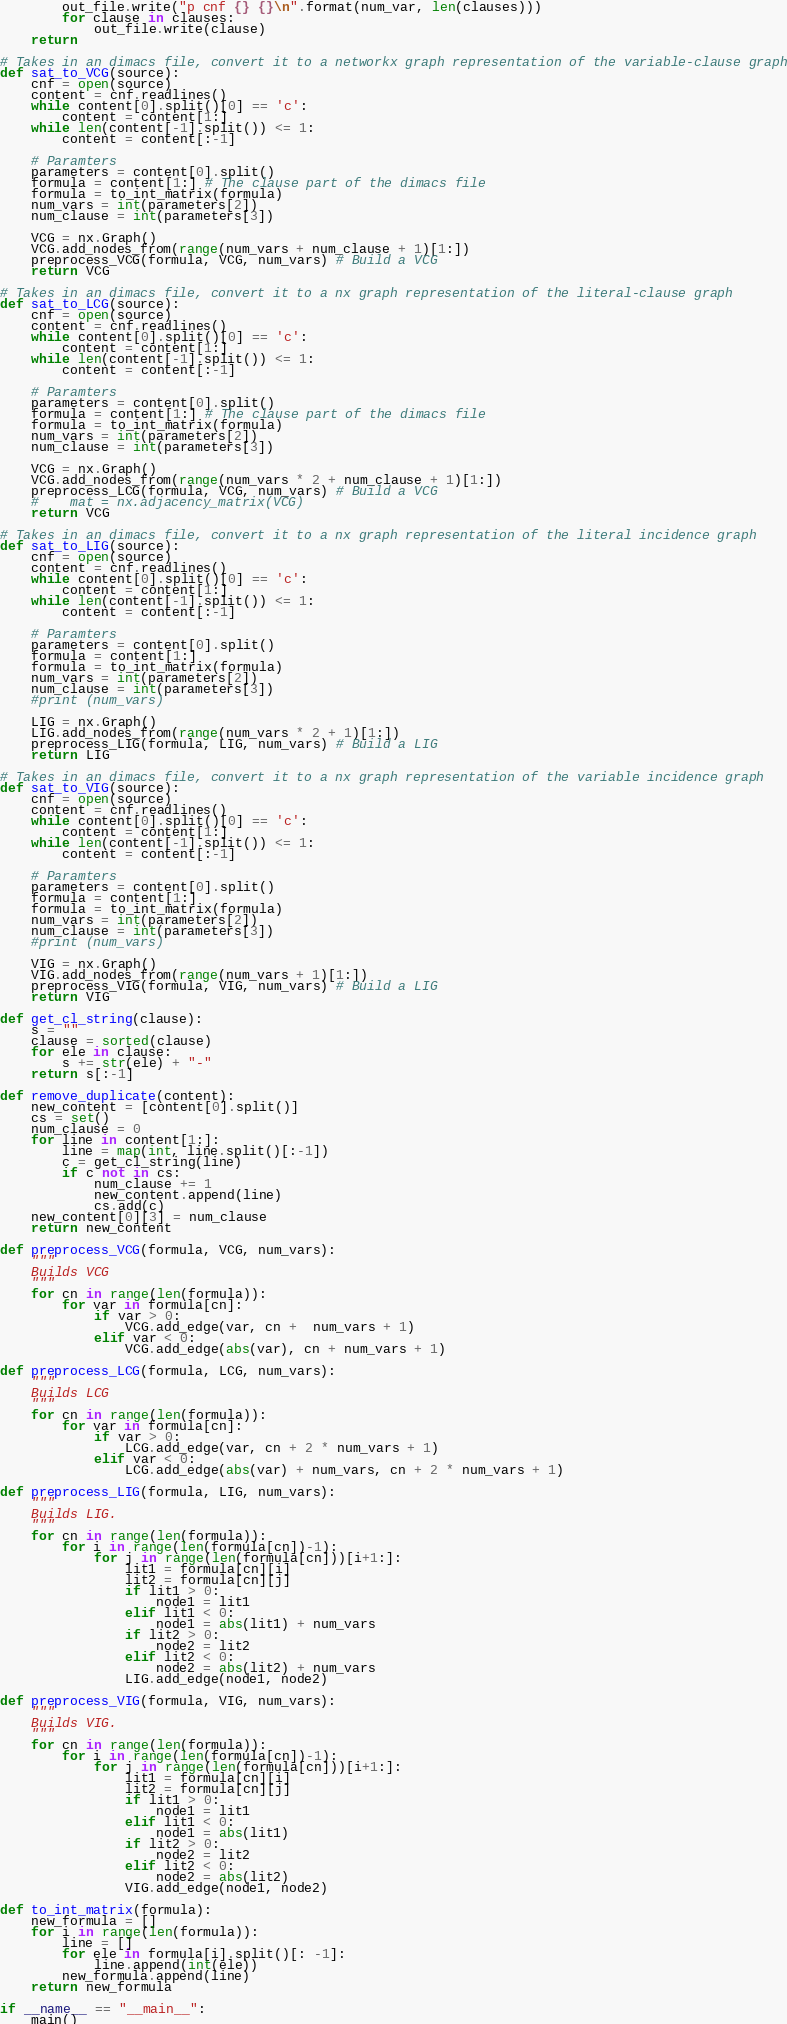Convert code to text. <code><loc_0><loc_0><loc_500><loc_500><_Python_>        out_file.write("p cnf {} {}\n".format(num_var, len(clauses)))
        for clause in clauses:
            out_file.write(clause)
    return

# Takes in an dimacs file, convert it to a networkx graph representation of the variable-clause graph
def sat_to_VCG(source):
    cnf = open(source)
    content = cnf.readlines()
    while content[0].split()[0] == 'c':
        content = content[1:]
    while len(content[-1].split()) <= 1:
        content = content[:-1]

    # Paramters
    parameters = content[0].split()
    formula = content[1:] # The clause part of the dimacs file
    formula = to_int_matrix(formula)
    num_vars = int(parameters[2])
    num_clause = int(parameters[3])

    VCG = nx.Graph()
    VCG.add_nodes_from(range(num_vars + num_clause + 1)[1:])
    preprocess_VCG(formula, VCG, num_vars) # Build a VCG
    return VCG

# Takes in an dimacs file, convert it to a nx graph representation of the literal-clause graph
def sat_to_LCG(source):
    cnf = open(source)
    content = cnf.readlines()
    while content[0].split()[0] == 'c':
        content = content[1:]
    while len(content[-1].split()) <= 1:
        content = content[:-1]

    # Paramters
    parameters = content[0].split()
    formula = content[1:] # The clause part of the dimacs file
    formula = to_int_matrix(formula)
    num_vars = int(parameters[2])
    num_clause = int(parameters[3])

    VCG = nx.Graph()
    VCG.add_nodes_from(range(num_vars * 2 + num_clause + 1)[1:])
    preprocess_LCG(formula, VCG, num_vars) # Build a VCG
    #    mat = nx.adjacency_matrix(VCG)
    return VCG

# Takes in an dimacs file, convert it to a nx graph representation of the literal incidence graph
def sat_to_LIG(source):
    cnf = open(source)
    content = cnf.readlines()
    while content[0].split()[0] == 'c':
        content = content[1:]
    while len(content[-1].split()) <= 1:
        content = content[:-1]

    # Paramters
    parameters = content[0].split()
    formula = content[1:]
    formula = to_int_matrix(formula)
    num_vars = int(parameters[2])
    num_clause = int(parameters[3])
    #print (num_vars)

    LIG = nx.Graph()
    LIG.add_nodes_from(range(num_vars * 2 + 1)[1:])
    preprocess_LIG(formula, LIG, num_vars) # Build a LIG
    return LIG

# Takes in an dimacs file, convert it to a nx graph representation of the variable incidence graph
def sat_to_VIG(source):
    cnf = open(source)
    content = cnf.readlines()
    while content[0].split()[0] == 'c':
        content = content[1:]
    while len(content[-1].split()) <= 1:
        content = content[:-1]

    # Paramters
    parameters = content[0].split()
    formula = content[1:]
    formula = to_int_matrix(formula)
    num_vars = int(parameters[2])
    num_clause = int(parameters[3])
    #print (num_vars)

    VIG = nx.Graph()
    VIG.add_nodes_from(range(num_vars + 1)[1:])
    preprocess_VIG(formula, VIG, num_vars) # Build a LIG
    return VIG

def get_cl_string(clause):
    s = ""
    clause = sorted(clause)
    for ele in clause:
        s += str(ele) + "-"
    return s[:-1]

def remove_duplicate(content):
    new_content = [content[0].split()]
    cs = set()
    num_clause = 0
    for line in content[1:]:
        line = map(int, line.split()[:-1])
        c = get_cl_string(line)
        if c not in cs:
            num_clause += 1
            new_content.append(line)
            cs.add(c)
    new_content[0][3] = num_clause
    return new_content

def preprocess_VCG(formula, VCG, num_vars):
    """
    Builds VCG
    """
    for cn in range(len(formula)):
        for var in formula[cn]:
            if var > 0:
                VCG.add_edge(var, cn +  num_vars + 1)
            elif var < 0:
                VCG.add_edge(abs(var), cn + num_vars + 1)

def preprocess_LCG(formula, LCG, num_vars):
    """
    Builds LCG
    """
    for cn in range(len(formula)):
        for var in formula[cn]:
            if var > 0:
                LCG.add_edge(var, cn + 2 * num_vars + 1)
            elif var < 0:
                LCG.add_edge(abs(var) + num_vars, cn + 2 * num_vars + 1)

def preprocess_LIG(formula, LIG, num_vars):
    """
    Builds LIG.
    """
    for cn in range(len(formula)):
        for i in range(len(formula[cn])-1):
            for j in range(len(formula[cn]))[i+1:]:
                lit1 = formula[cn][i]
                lit2 = formula[cn][j]
                if lit1 > 0:
                    node1 = lit1
                elif lit1 < 0:
                    node1 = abs(lit1) + num_vars
                if lit2 > 0:
                    node2 = lit2
                elif lit2 < 0:
                    node2 = abs(lit2) + num_vars
                LIG.add_edge(node1, node2)

def preprocess_VIG(formula, VIG, num_vars):
    """
    Builds VIG.
    """
    for cn in range(len(formula)):
        for i in range(len(formula[cn])-1):
            for j in range(len(formula[cn]))[i+1:]:
                lit1 = formula[cn][i]
                lit2 = formula[cn][j]
                if lit1 > 0:
                    node1 = lit1
                elif lit1 < 0:
                    node1 = abs(lit1)
                if lit2 > 0:
                    node2 = lit2
                elif lit2 < 0:
                    node2 = abs(lit2)
                VIG.add_edge(node1, node2)

def to_int_matrix(formula):
    new_formula = []
    for i in range(len(formula)):
        line = []
        for ele in formula[i].split()[: -1]:
            line.append(int(ele))
        new_formula.append(line)
    return new_formula

if __name__ == "__main__":
    main()
</code> 